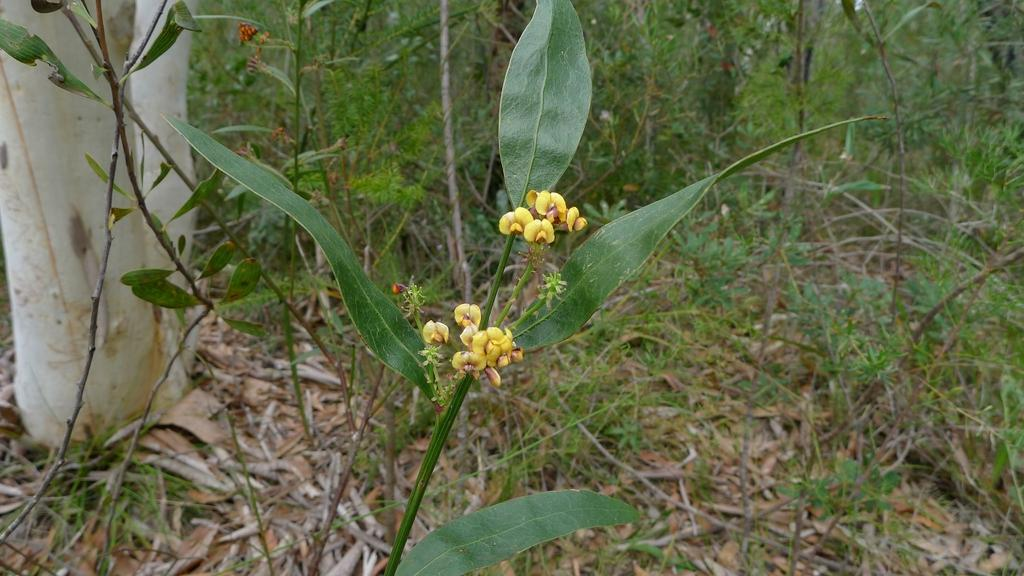What types of living organisms can be seen in the image? Flowers and plants can be seen in the image. Can you describe any specific features of the plants in the image? The bark of a tree is visible on the left side of the image. Where is the kitten playing with a brass object in the image? There is no kitten or brass object present in the image. 